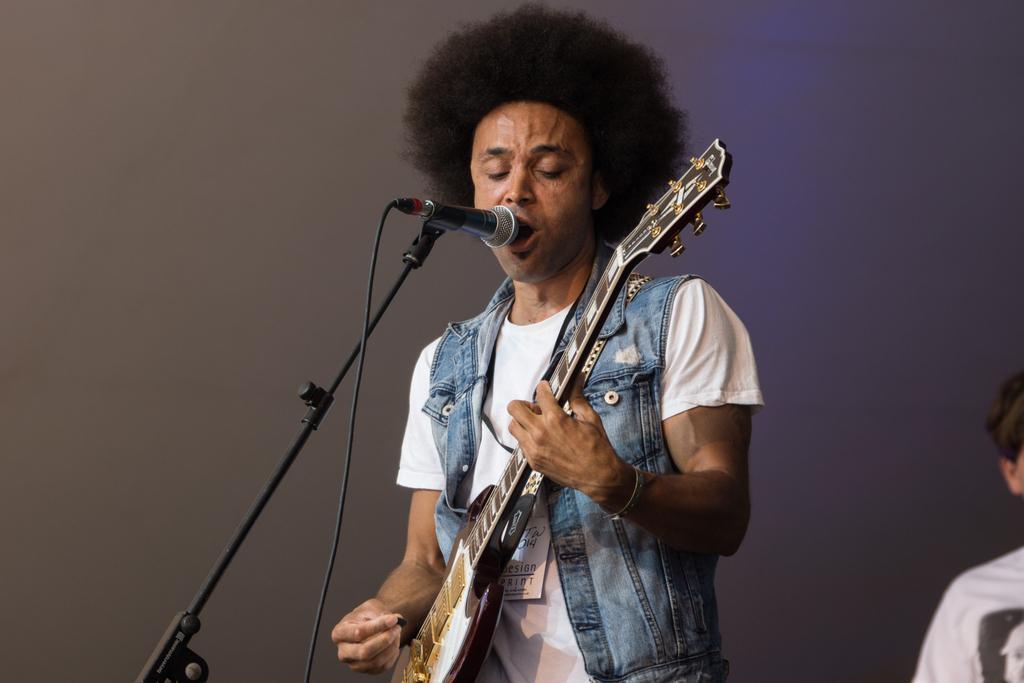Please provide a concise description of this image. In this image the man wearing white t-shirt and blue jacket is playing a guitar and singing. In front of him, there is mic along with mic stand. The background is gray in color. 